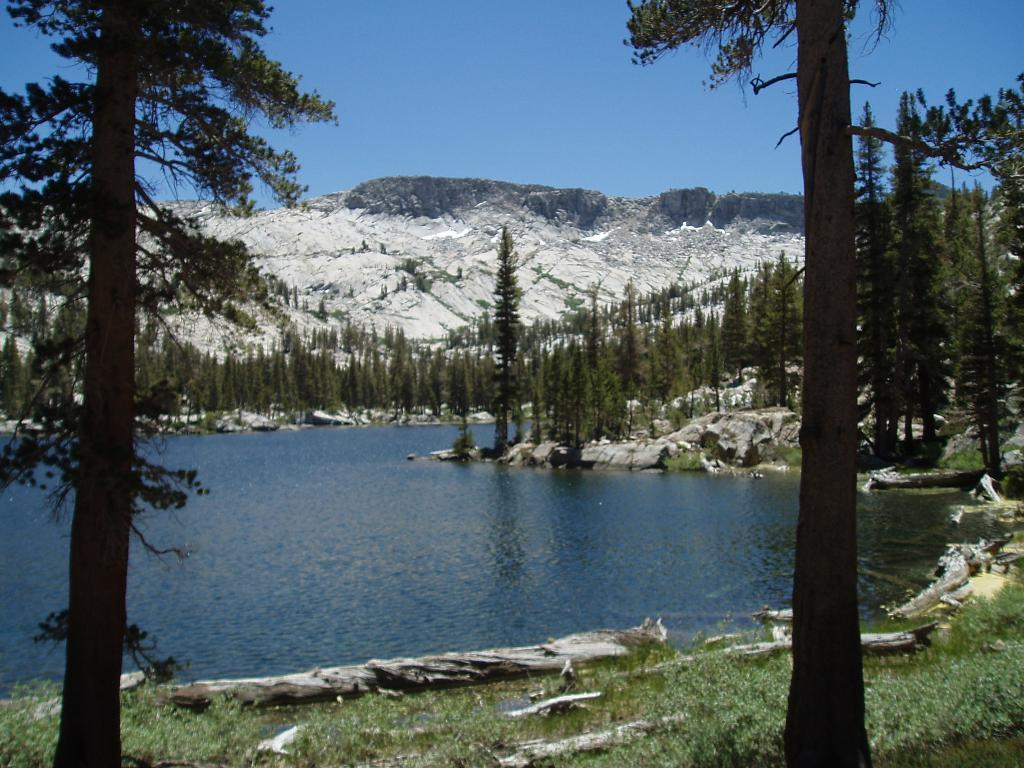What type of vegetation is present in the image? There are many trees in the image. What is the color of the grass at the bottom of the image? The grass at the bottom of the image is green. What can be seen in the middle of the image? There is water in the middle of the image. What type of landscape feature is visible in the background of the image? There are mountains in the background of the image. What is visible at the top of the image? The sky is visible at the top of the image. How many hands are visible in the image? There are no hands visible in the image. What type of organization is depicted in the image? There is no organization depicted in the image; it features natural elements such as trees, grass, water, mountains, and sky. 